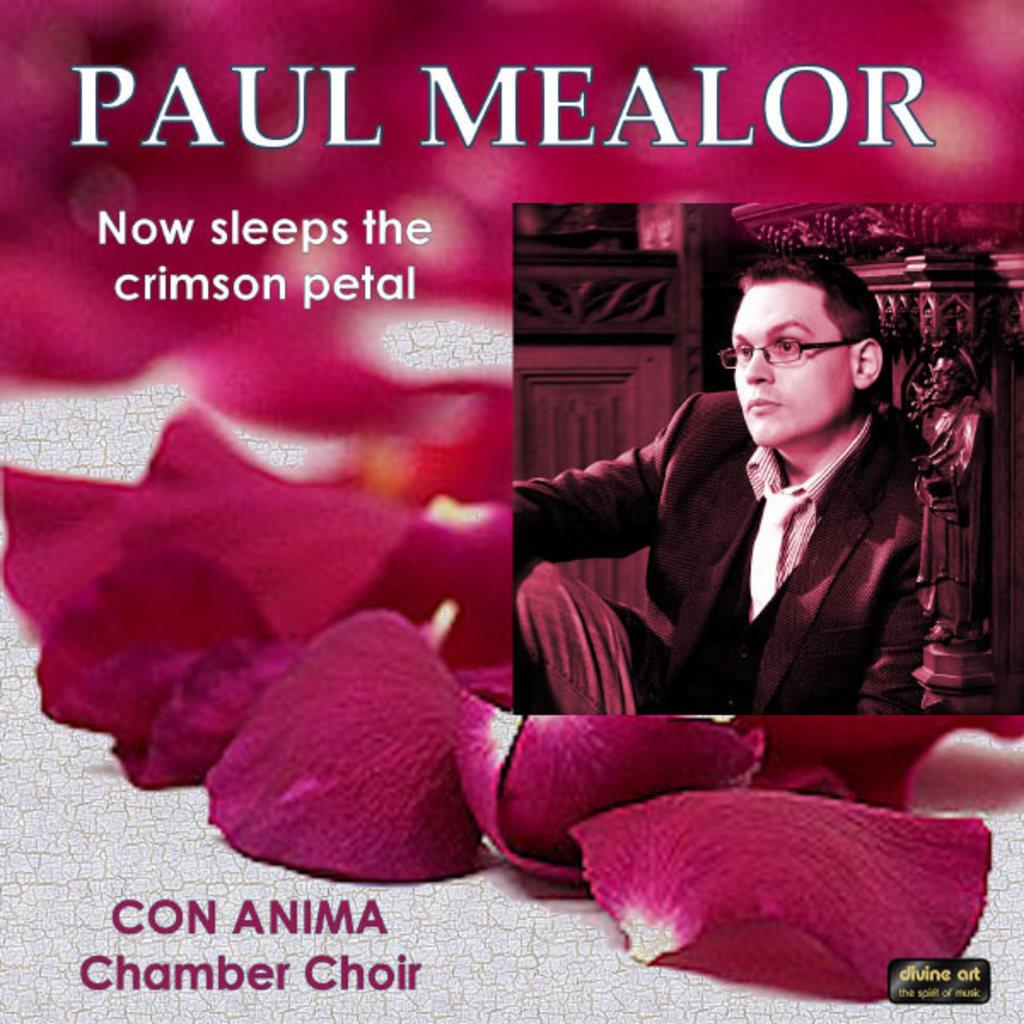What type of visual is the image? The image is a poster. Where is the text located on the poster? There is text at the top and bottom of the poster. What is in the center of the poster? There is a person and flower petals in the center of the poster. What hobbies does the person in the poster have? There is no information about the person's hobbies in the image. How many frogs are sitting on the flower petals in the poster? There are no frogs present in the image. 